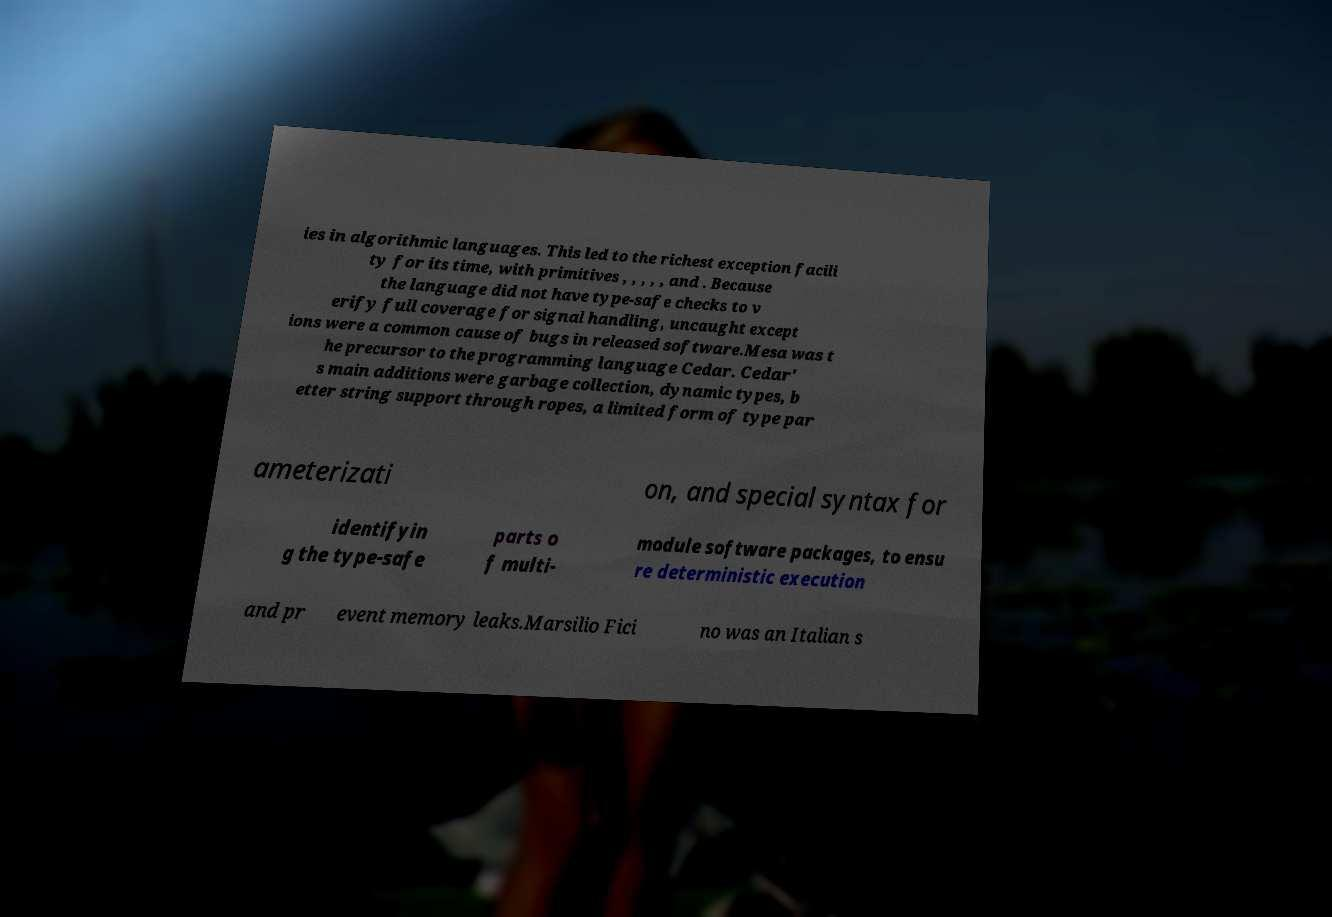I need the written content from this picture converted into text. Can you do that? ies in algorithmic languages. This led to the richest exception facili ty for its time, with primitives , , , , , and . Because the language did not have type-safe checks to v erify full coverage for signal handling, uncaught except ions were a common cause of bugs in released software.Mesa was t he precursor to the programming language Cedar. Cedar' s main additions were garbage collection, dynamic types, b etter string support through ropes, a limited form of type par ameterizati on, and special syntax for identifyin g the type-safe parts o f multi- module software packages, to ensu re deterministic execution and pr event memory leaks.Marsilio Fici no was an Italian s 